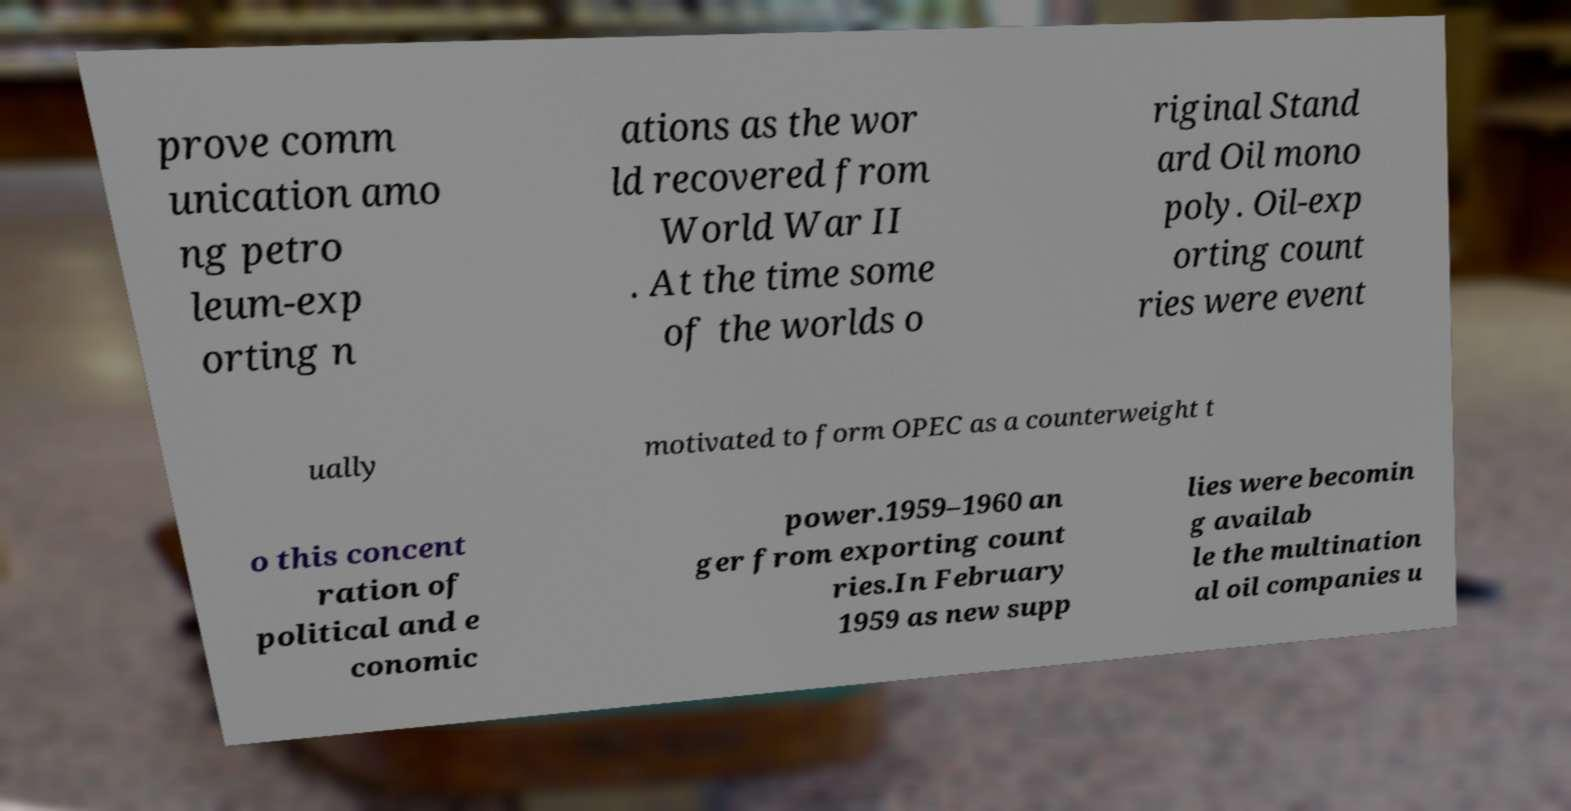Please read and relay the text visible in this image. What does it say? prove comm unication amo ng petro leum-exp orting n ations as the wor ld recovered from World War II . At the time some of the worlds o riginal Stand ard Oil mono poly. Oil-exp orting count ries were event ually motivated to form OPEC as a counterweight t o this concent ration of political and e conomic power.1959–1960 an ger from exporting count ries.In February 1959 as new supp lies were becomin g availab le the multination al oil companies u 